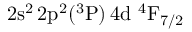<formula> <loc_0><loc_0><loc_500><loc_500>2 s ^ { 2 } \, 2 p ^ { 2 } ( ^ { 3 } P ) \, 4 d ^ { 4 } F _ { 7 / 2 }</formula> 